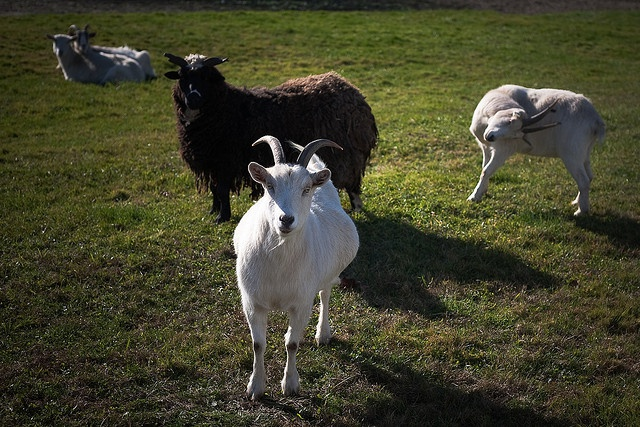Describe the objects in this image and their specific colors. I can see sheep in black, darkgreen, and gray tones, sheep in black, gray, and white tones, sheep in black, gray, and lightgray tones, sheep in black, gray, and darkgray tones, and sheep in black, gray, darkgray, and darkgreen tones in this image. 